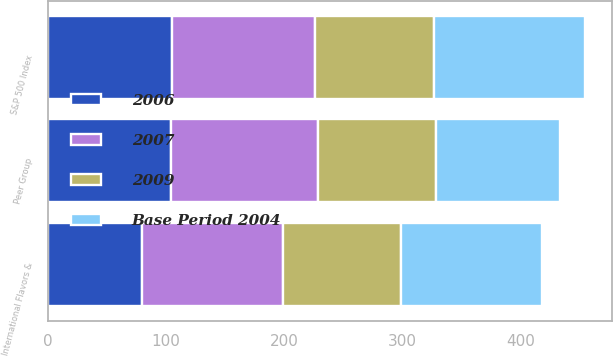Convert chart to OTSL. <chart><loc_0><loc_0><loc_500><loc_500><stacked_bar_chart><ecel><fcel>International Flavors &<fcel>S&P 500 Index<fcel>Peer Group<nl><fcel>2009<fcel>100<fcel>100<fcel>100<nl><fcel>2006<fcel>79.79<fcel>104.91<fcel>104.58<nl><fcel>2007<fcel>119.4<fcel>121.48<fcel>124.09<nl><fcel>Base Period 2004<fcel>118.97<fcel>128.16<fcel>104.91<nl></chart> 